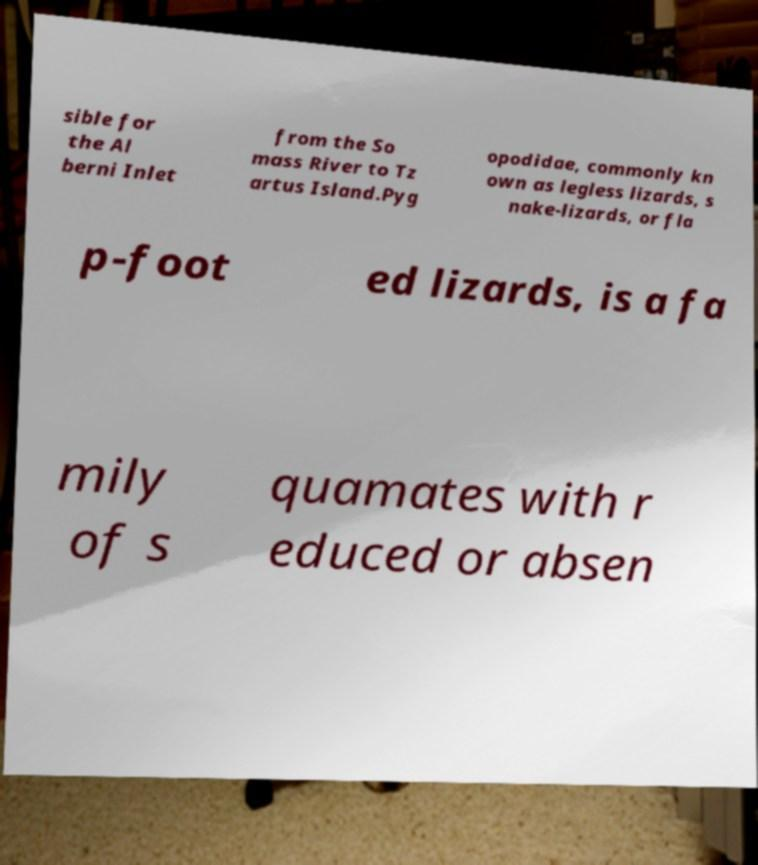Can you read and provide the text displayed in the image?This photo seems to have some interesting text. Can you extract and type it out for me? sible for the Al berni Inlet from the So mass River to Tz artus Island.Pyg opodidae, commonly kn own as legless lizards, s nake-lizards, or fla p-foot ed lizards, is a fa mily of s quamates with r educed or absen 